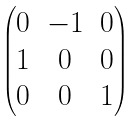<formula> <loc_0><loc_0><loc_500><loc_500>\begin{pmatrix} 0 & - 1 & 0 \\ 1 & 0 & 0 \\ 0 & 0 & 1 \end{pmatrix}</formula> 